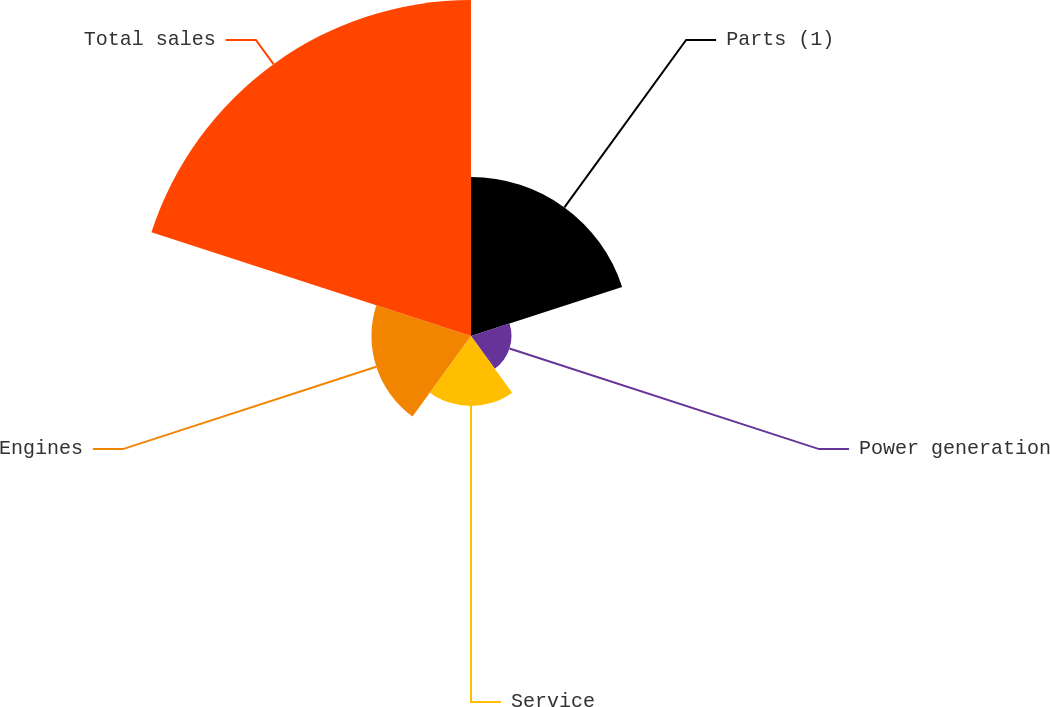Convert chart to OTSL. <chart><loc_0><loc_0><loc_500><loc_500><pie_chart><fcel>Parts (1)<fcel>Power generation<fcel>Service<fcel>Engines<fcel>Total sales<nl><fcel>22.54%<fcel>5.74%<fcel>9.93%<fcel>14.12%<fcel>47.66%<nl></chart> 